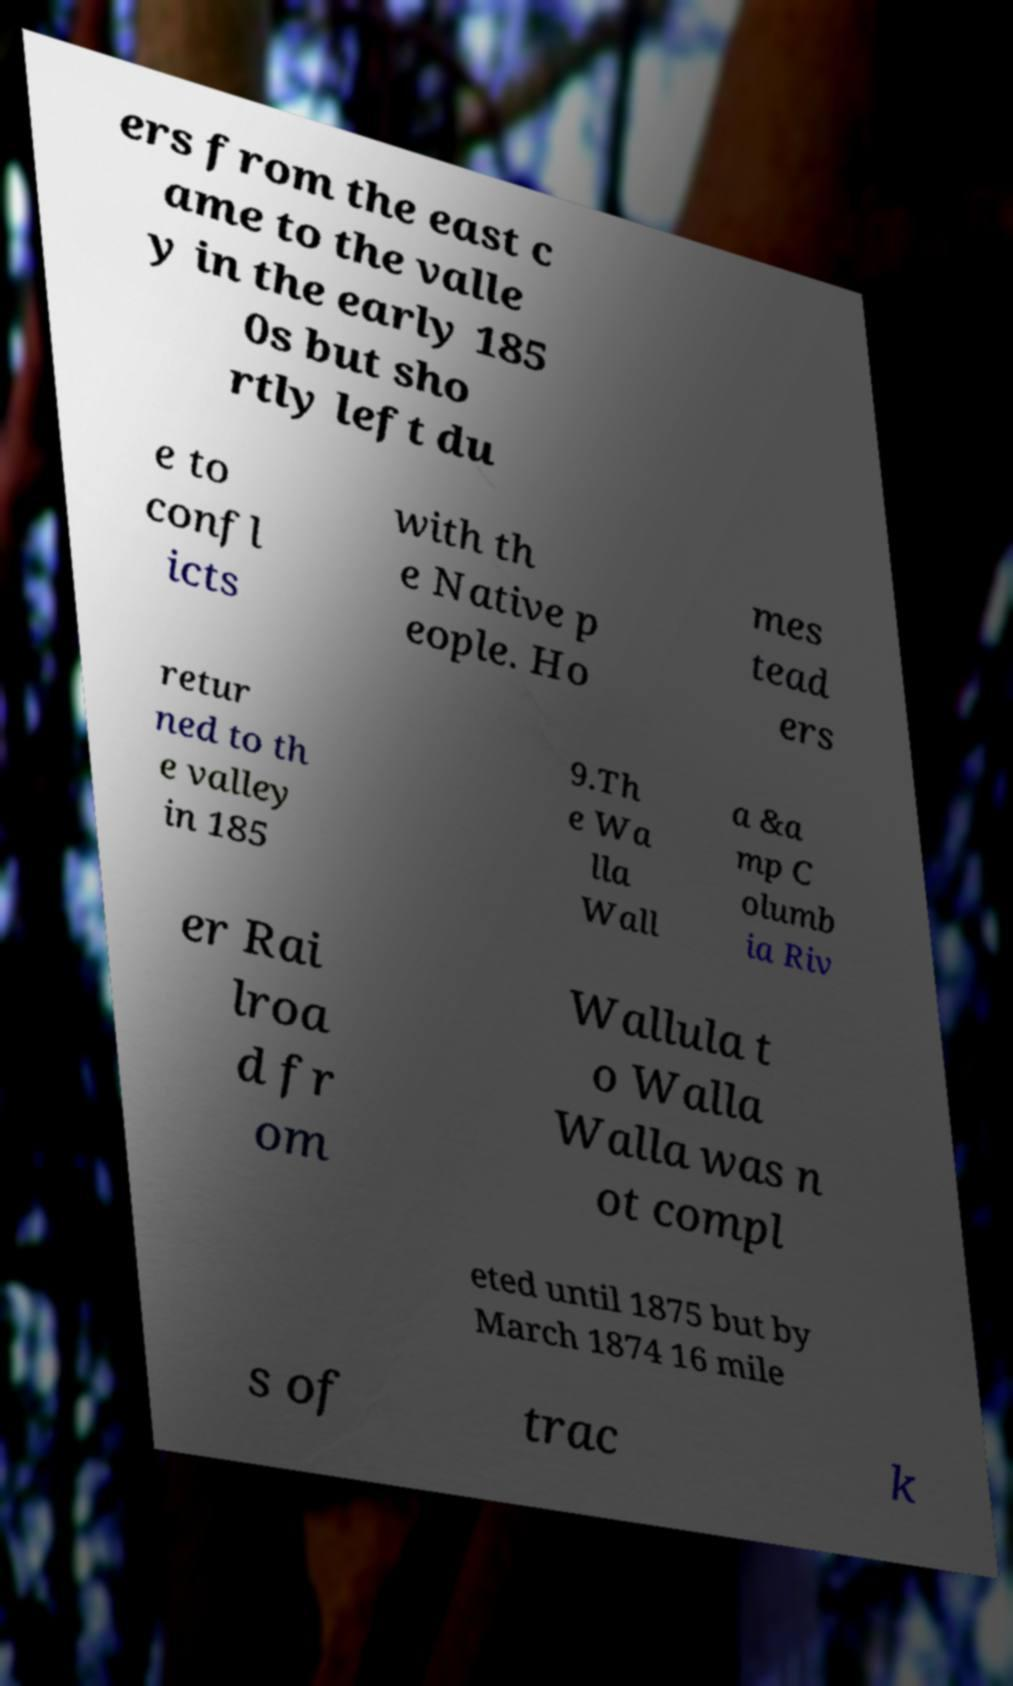Could you assist in decoding the text presented in this image and type it out clearly? ers from the east c ame to the valle y in the early 185 0s but sho rtly left du e to confl icts with th e Native p eople. Ho mes tead ers retur ned to th e valley in 185 9.Th e Wa lla Wall a &a mp C olumb ia Riv er Rai lroa d fr om Wallula t o Walla Walla was n ot compl eted until 1875 but by March 1874 16 mile s of trac k 